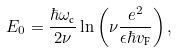Convert formula to latex. <formula><loc_0><loc_0><loc_500><loc_500>E _ { 0 } = \frac { \hbar { \omega } _ { \text {c} } } { 2 \nu } \ln \left ( \nu \frac { e ^ { 2 } } { \epsilon \hbar { v } _ { \text {F} } } \right ) ,</formula> 